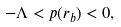Convert formula to latex. <formula><loc_0><loc_0><loc_500><loc_500>- \Lambda < p ( r _ { b } ) < 0 ,</formula> 